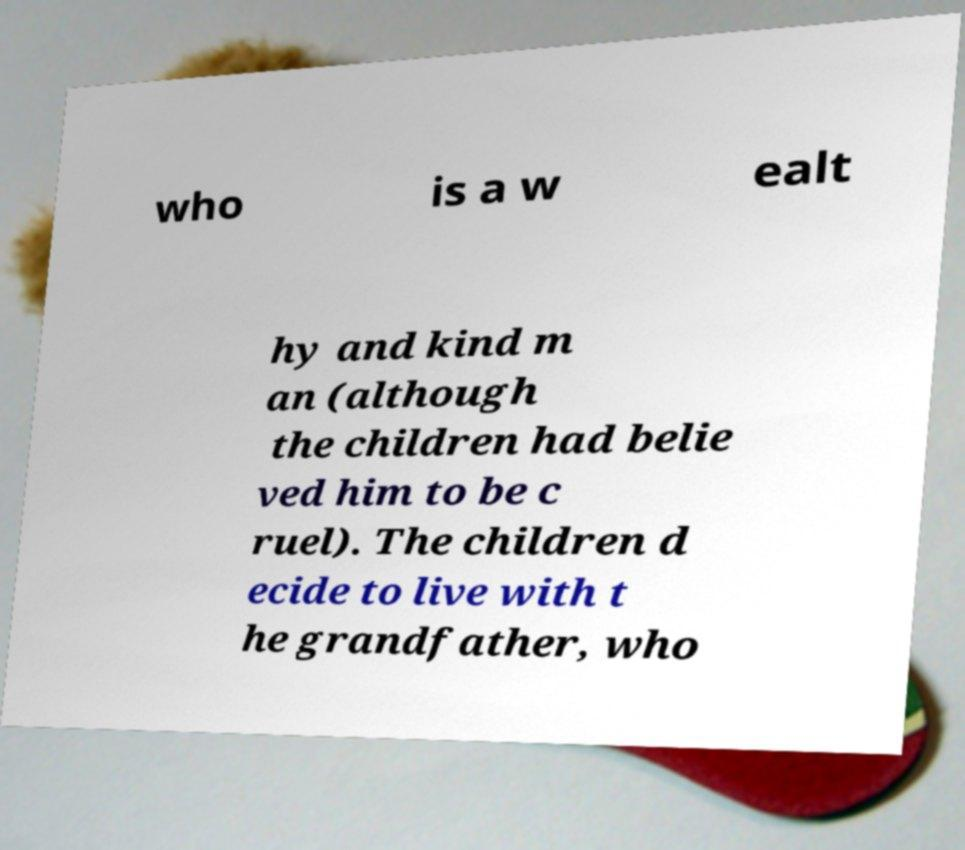Can you accurately transcribe the text from the provided image for me? who is a w ealt hy and kind m an (although the children had belie ved him to be c ruel). The children d ecide to live with t he grandfather, who 